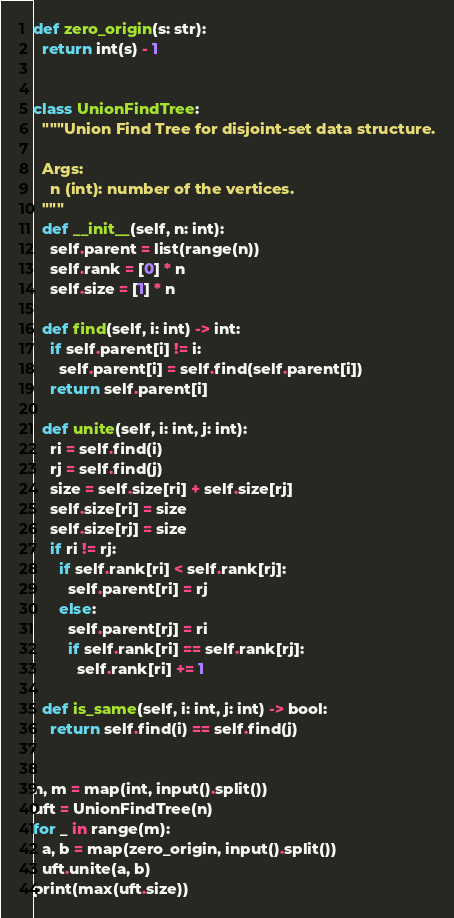<code> <loc_0><loc_0><loc_500><loc_500><_Python_>def zero_origin(s: str):
  return int(s) - 1


class UnionFindTree:
  """Union Find Tree for disjoint-set data structure.

  Args:
    n (int): number of the vertices.
  """
  def __init__(self, n: int):
    self.parent = list(range(n))
    self.rank = [0] * n
    self.size = [1] * n

  def find(self, i: int) -> int:
    if self.parent[i] != i:
      self.parent[i] = self.find(self.parent[i])
    return self.parent[i]

  def unite(self, i: int, j: int):
    ri = self.find(i)
    rj = self.find(j)
    size = self.size[ri] + self.size[rj]
    self.size[ri] = size
    self.size[rj] = size
    if ri != rj:
      if self.rank[ri] < self.rank[rj]:
        self.parent[ri] = rj
      else:
        self.parent[rj] = ri
        if self.rank[ri] == self.rank[rj]:
          self.rank[ri] += 1

  def is_same(self, i: int, j: int) -> bool:
    return self.find(i) == self.find(j)


n, m = map(int, input().split())
uft = UnionFindTree(n)
for _ in range(m):
  a, b = map(zero_origin, input().split())
  uft.unite(a, b)
print(max(uft.size))</code> 